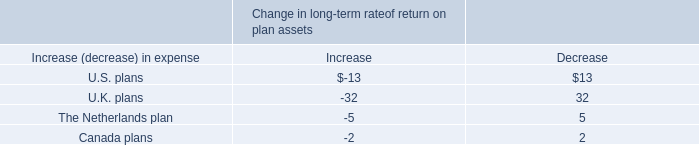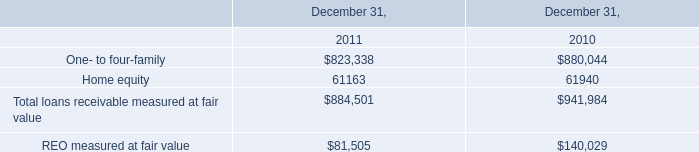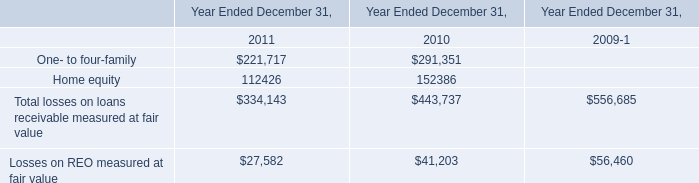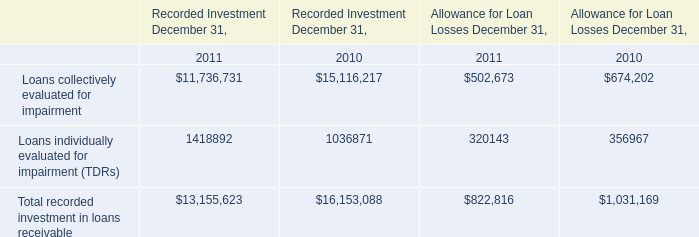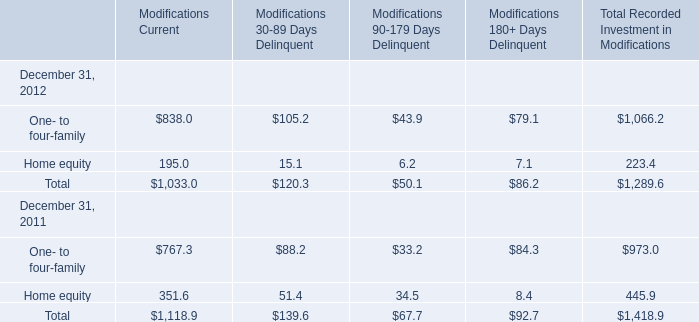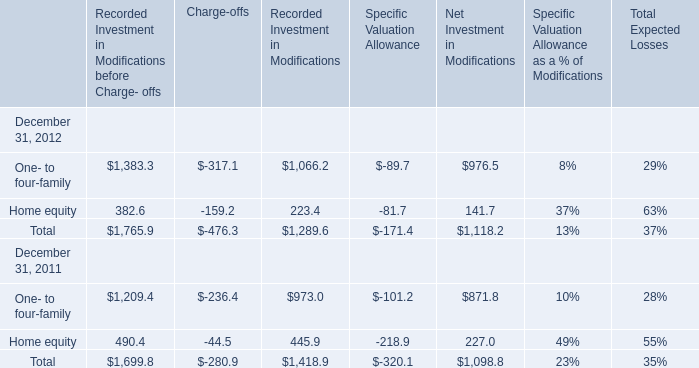what is the increase in the value of goodwill balances during 2008 and 2009? 
Computations: ((6.1 / 5.6) - 1)
Answer: 0.08929. 